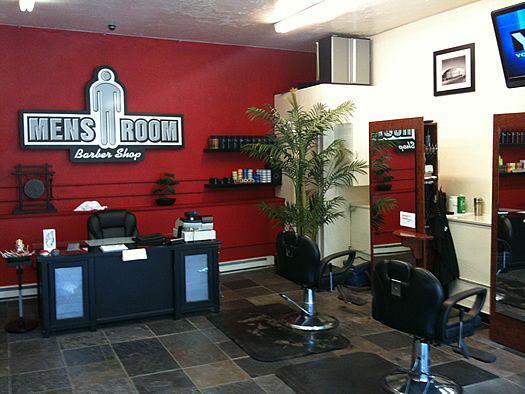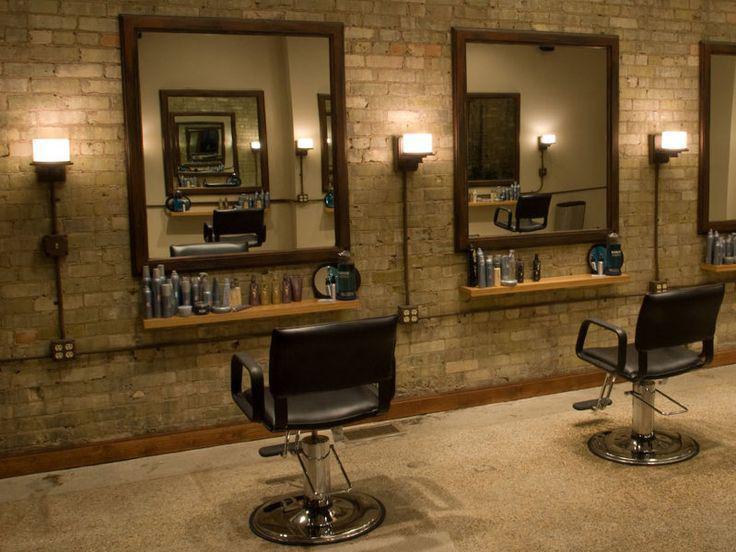The first image is the image on the left, the second image is the image on the right. Given the left and right images, does the statement "The decor in one image features black surfaces predominantly." hold true? Answer yes or no. No. 